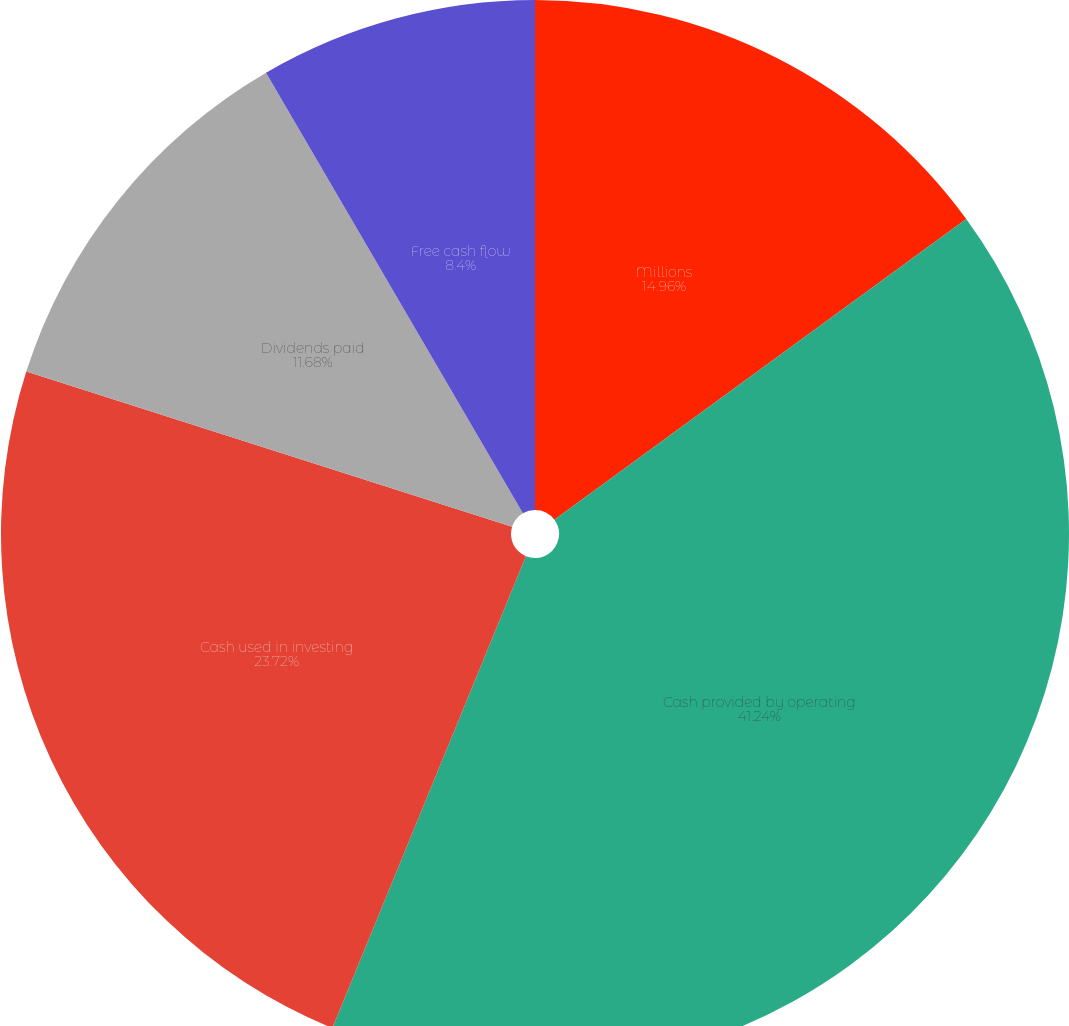Convert chart. <chart><loc_0><loc_0><loc_500><loc_500><pie_chart><fcel>Millions<fcel>Cash provided by operating<fcel>Cash used in investing<fcel>Dividends paid<fcel>Free cash flow<nl><fcel>14.96%<fcel>41.23%<fcel>23.72%<fcel>11.68%<fcel>8.4%<nl></chart> 